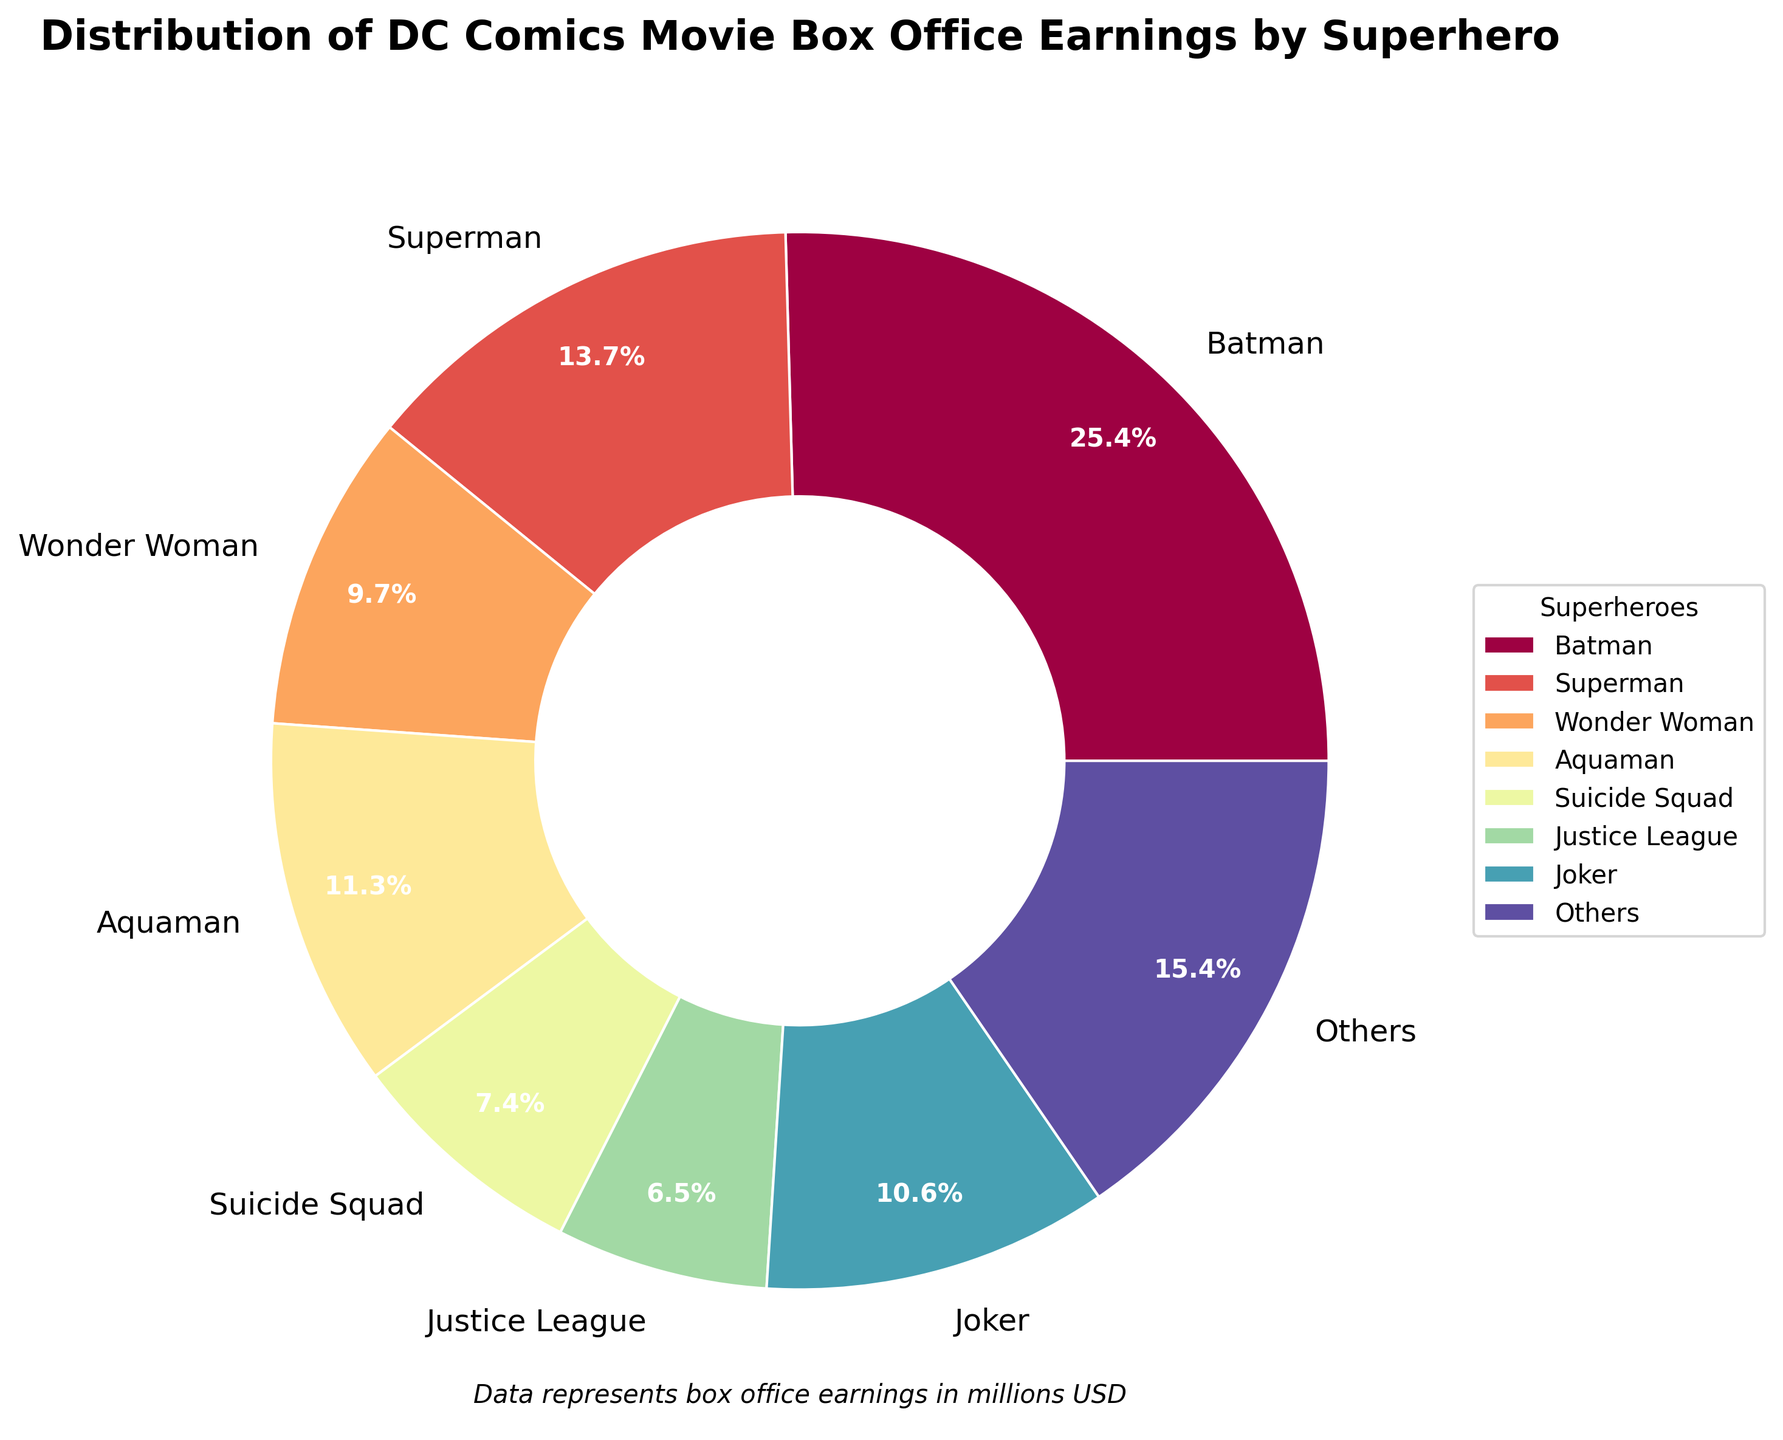What percentage of the total box office earnings does Batman represent? Batman's earnings are 2584 million USD. To find the percentage, divide Batman's earnings by the total earnings and multiply by 100. The total earnings are the sum of earnings from all superheroes (9980 million USD). So, (2584 / 9980) * 100 ≈ 25.9%
Answer: 25.9% Which superhero has the second highest box office earnings? By looking at the sizes of the pie chart segments, the superhero with the second largest segment is Superman with 1392 million USD.
Answer: Superman What are the total box office earnings for Superman and Wonder Woman combined? Superman and Wonder Woman have earnings of 1392 million USD and 989 million USD, respectively. Adding these together: 1392 + 989 = 2381 million USD.
Answer: 2381 million USD Who has a larger share of the total box office earnings, The Flash or Shazam? Comparing the sizes of the pie chart segments, Shazam's segment (366 million USD) is larger than The Flash's segment (270 million USD).
Answer: Shazam How much more did Joker earn compared to Aquaman? Joker's earnings are 1074 million USD, while Aquaman's are 1148 million USD. The difference is 1148 - 1074 = 74 million USD.
Answer: 74 million USD What percentage of the total box office earnings do the "Others" category represent? First, calculate the total earnings for superheroes not individually listed: Cyborg (15), Green Lantern (219), Catwoman (82), Constantine (230), Watchmen (185), and Harley Quinn (201). Summing these: 15 + 219 + 82 + 230 + 185 + 201 = 932 million USD. Then, divide by total earnings and multiply by 100: (932 / 9980) * 100 ≈ 9.3%.
Answer: 9.3% Which superhero has the smallest individual earnings on the chart? By the size of the pie chart segments and given the data, Cyborg has the smallest individual earnings with 15 million USD.
Answer: Cyborg If we combine the earnings of Suicide Squad and Justice League, would it surpass Batman's earnings? Suicide Squad's earnings are 747 million USD and Justice League's are 658 million USD. Combined: 747 + 658 = 1405 million USD, which is less than Batman's 2584 million USD.
Answer: No What percentage of the pie do Aquaman's and Wonder Woman's earnings make together? Aquaman's earnings are 1148 million USD and Wonder Woman's are 989 million USD. Combined, they are 1148 + 989 = 2137 million USD. The total earnings are 9980 million USD. So, (2137 / 9980) * 100 ≈ 21.4%.
Answer: 21.4% What colors represent Batman and Superman in the pie chart? According to the color scheme from the Spectral colormap used in the chart generation, specific colors are assigned, but one could refer to the visual elements of the supplied chart. Typically, Batman and Superman would have distinctly different colors for easy identification.
Answer: Batman: (color), Superman: (color) 